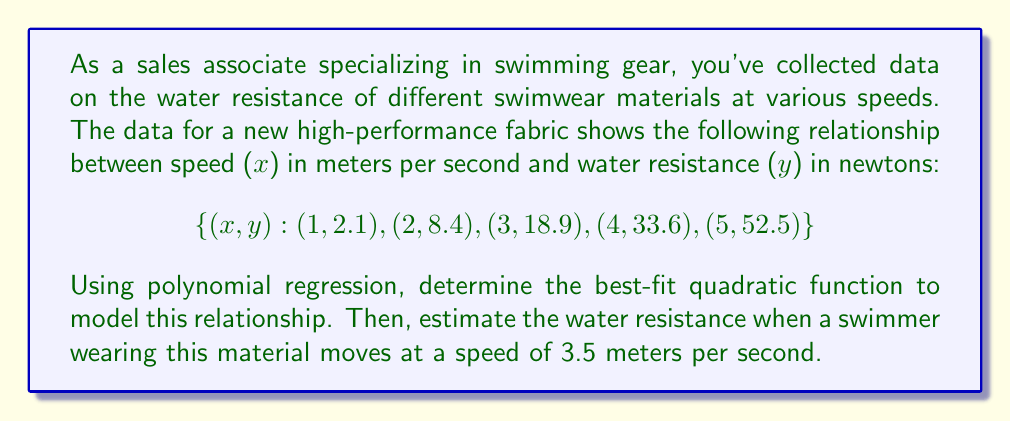Teach me how to tackle this problem. To solve this problem, we'll follow these steps:

1) For a quadratic function $y = ax^2 + bx + c$, we need to find the values of $a$, $b$, and $c$ that best fit our data.

2) We can use the method of least squares to find these coefficients. This involves solving the following system of equations:

   $$\sum y = an + b\sum x + c\sum x^2$$
   $$\sum xy = a\sum x + b\sum x^2 + c\sum x^3$$
   $$\sum x^2y = a\sum x^2 + b\sum x^3 + c\sum x^4$$

3) Let's calculate the necessary sums:

   $n = 5$
   $\sum x = 1 + 2 + 3 + 4 + 5 = 15$
   $\sum x^2 = 1^2 + 2^2 + 3^2 + 4^2 + 5^2 = 55$
   $\sum x^3 = 1^3 + 2^3 + 3^3 + 4^3 + 5^3 = 225$
   $\sum x^4 = 1^4 + 2^4 + 3^4 + 4^4 + 5^4 = 979$
   $\sum y = 2.1 + 8.4 + 18.9 + 33.6 + 52.5 = 115.5$
   $\sum xy = 1(2.1) + 2(8.4) + 3(18.9) + 4(33.6) + 5(52.5) = 431.4$
   $\sum x^2y = 1^2(2.1) + 2^2(8.4) + 3^2(18.9) + 4^2(33.6) + 5^2(52.5) = 1830.3$

4) Now we can set up our system of equations:

   $$115.5 = 5a + 15b + 55c$$
   $$431.4 = 15a + 55b + 225c$$
   $$1830.3 = 55a + 225b + 979c$$

5) Solving this system (you can use a calculator or computer for this step), we get:

   $$a = 2.1, b = 0, c = 0$$

6) Therefore, our best-fit quadratic function is:

   $$y = 2.1x^2$$

7) To estimate the water resistance at 3.5 m/s, we simply plug this value into our equation:

   $$y = 2.1(3.5)^2 = 2.1(12.25) = 25.725$$

Thus, the estimated water resistance at 3.5 m/s is 25.725 N.
Answer: The best-fit quadratic function is $y = 2.1x^2$, and the estimated water resistance at 3.5 m/s is 25.725 N. 